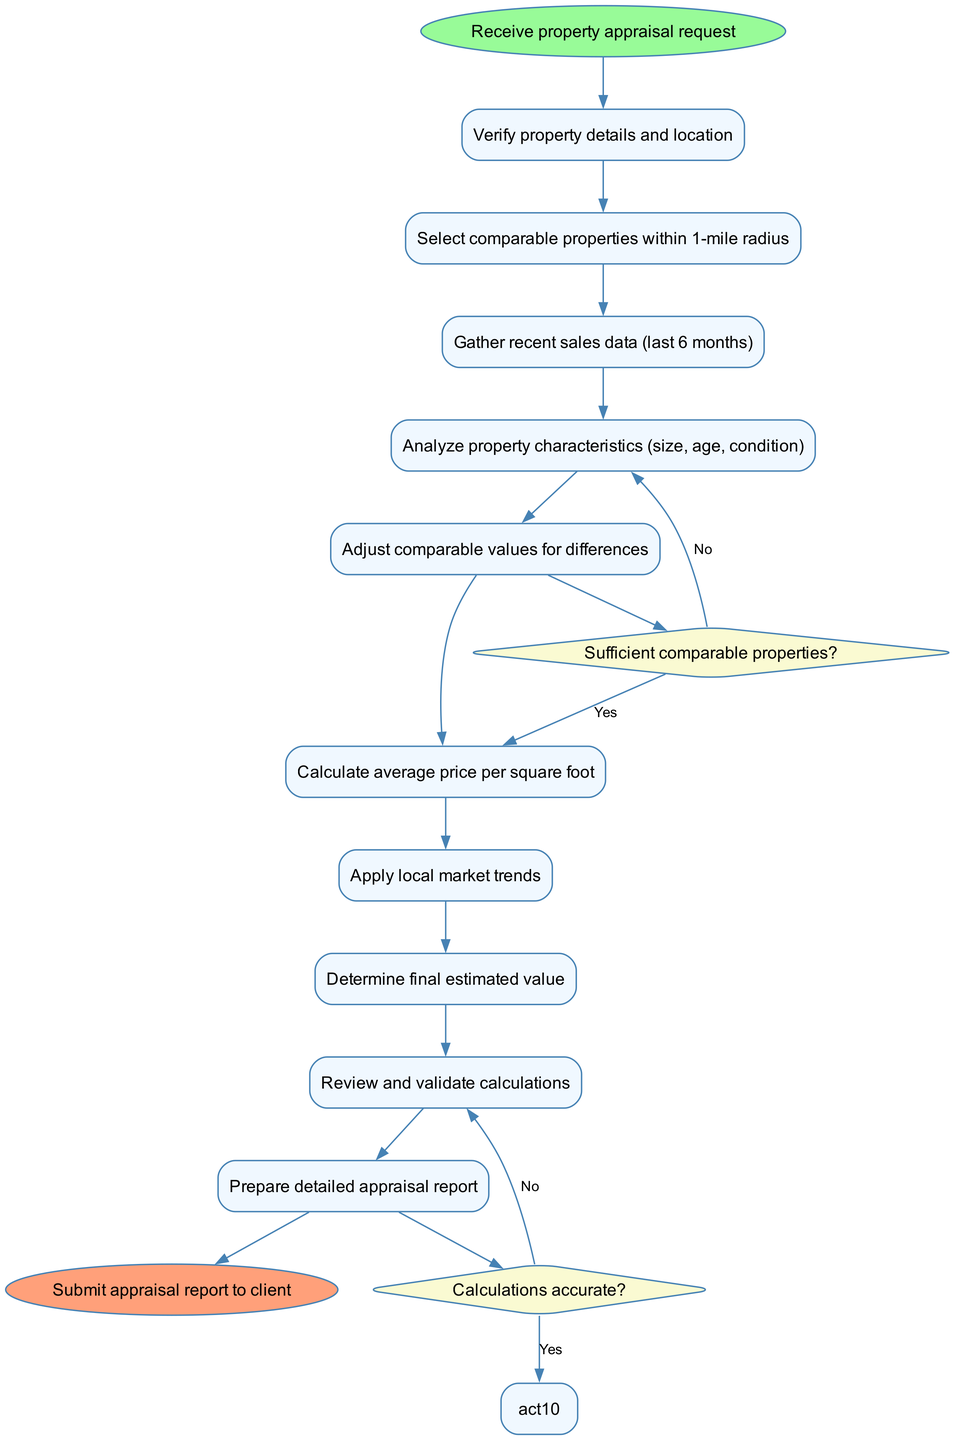What is the first activity in the workflow? The first activity in the workflow is identified at the start node, which is directly connected to the first activity. The start node points to "Verify property details and location" as the first activity following the appraisal request.
Answer: Verify property details and location How many activities are there in total? By counting the nodes labeled as activities in the diagram, we find 10 distinct activities listed. This number is obtained by simply enumerating each activity connected in sequence after the start node.
Answer: 10 What is the last decision point in the workflow? The last decision point is determined by looking at the flow of activities after the last activity node. The last decision is shown before the final activity of "Finalize report", which is followed by either continuing or revising based on accuracy.
Answer: Calculations accurate? What happens if there are not sufficient comparable properties? The diagram indicates that if the answer to the question "Sufficient comparable properties?" is "No", then the workflow directs to the "Expand search radius" activity, thus guiding the property appraiser to search for additional comparable properties.
Answer: Expand search radius What is the final output of the workflow? The ultimate output of the workflow is specified at the end node, which indicates what is produced after all the previous steps have been completed. The output is the appraisal report which is submitted to the client.
Answer: Submit appraisal report to client How many decisions are present in the workflow? We can deduce the number of decisions by examining the diamond-shaped nodes that pose questions within the diagram. There are 2 decision points depicted in the workflow according to the data provided.
Answer: 2 What is the relation between the "Analyze property characteristics" and "Adjust comparable values for differences"? The relationship is sequential; after analyzing the property characteristics, the next step in the workflow is to "Adjust comparable values for differences", indicating that the analysis informs the adjustment process which is logically a follow-up activity.
Answer: Sequential relation Which activity comes before "Prepare detailed appraisal report"? To determine which activity precedes "Prepare detailed appraisal report," we follow the flow from the last few activities and identify that "Review and validate calculations" is the activity directly leading into the preparation of the appraisal report.
Answer: Review and validate calculations 